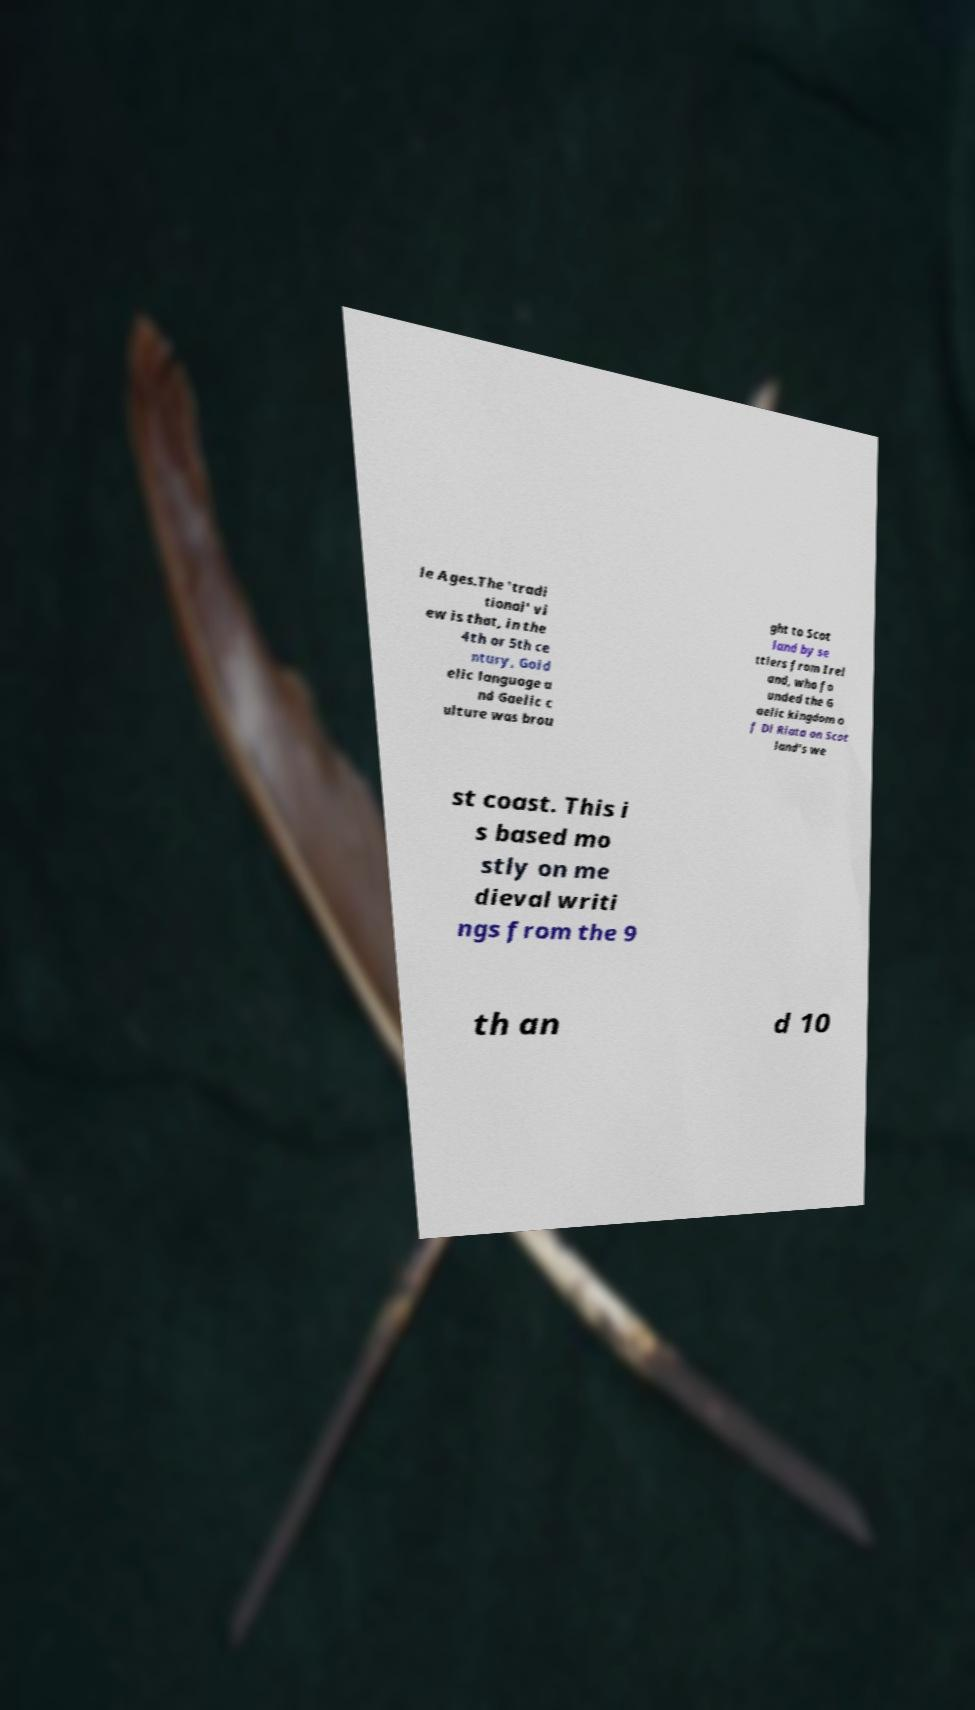I need the written content from this picture converted into text. Can you do that? le Ages.The 'tradi tional' vi ew is that, in the 4th or 5th ce ntury, Goid elic language a nd Gaelic c ulture was brou ght to Scot land by se ttlers from Irel and, who fo unded the G aelic kingdom o f Dl Riata on Scot land's we st coast. This i s based mo stly on me dieval writi ngs from the 9 th an d 10 